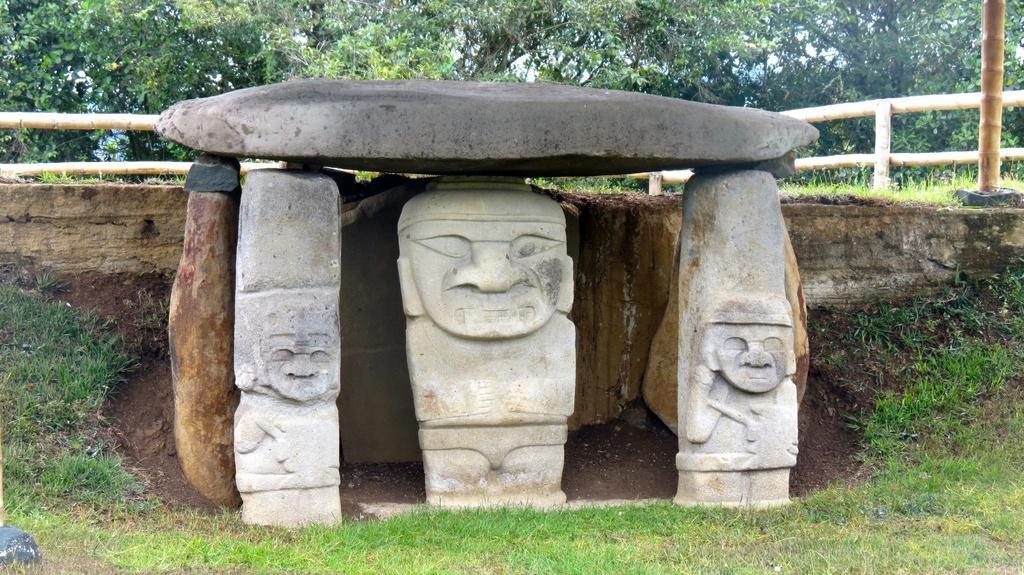Describe this image in one or two sentences. In this picture we can see few carving stones and grass, in the background we can find few trees and wooden fence. 